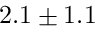Convert formula to latex. <formula><loc_0><loc_0><loc_500><loc_500>2 . 1 \pm 1 . 1</formula> 